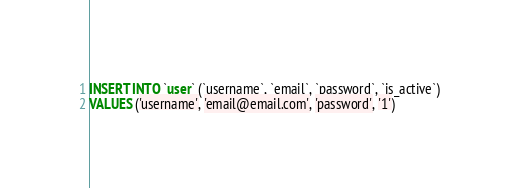Convert code to text. <code><loc_0><loc_0><loc_500><loc_500><_SQL_>INSERT INTO `user` (`username`, `email`, `password`, `is_active`) 
VALUES ('username', 'email@email.com', 'password', '1')</code> 